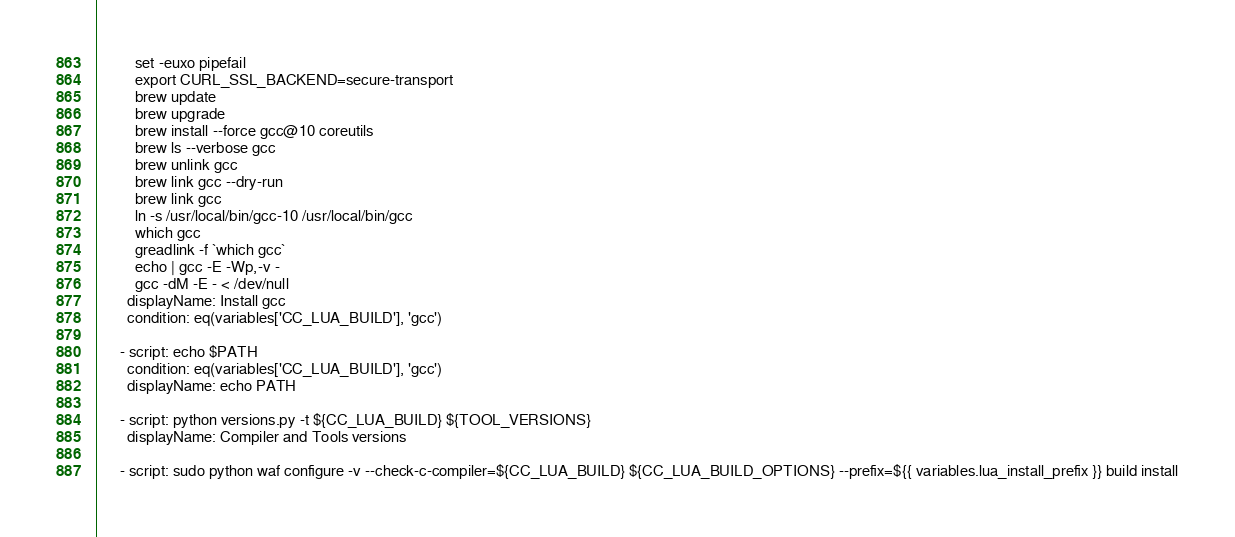<code> <loc_0><loc_0><loc_500><loc_500><_YAML_>          set -euxo pipefail
          export CURL_SSL_BACKEND=secure-transport
          brew update
          brew upgrade
          brew install --force gcc@10 coreutils
          brew ls --verbose gcc
          brew unlink gcc
          brew link gcc --dry-run
          brew link gcc
          ln -s /usr/local/bin/gcc-10 /usr/local/bin/gcc
          which gcc
          greadlink -f `which gcc`
          echo | gcc -E -Wp,-v -
          gcc -dM -E - < /dev/null
        displayName: Install gcc
        condition: eq(variables['CC_LUA_BUILD'], 'gcc')

      - script: echo $PATH
        condition: eq(variables['CC_LUA_BUILD'], 'gcc')
        displayName: echo PATH

      - script: python versions.py -t ${CC_LUA_BUILD} ${TOOL_VERSIONS}
        displayName: Compiler and Tools versions

      - script: sudo python waf configure -v --check-c-compiler=${CC_LUA_BUILD} ${CC_LUA_BUILD_OPTIONS} --prefix=${{ variables.lua_install_prefix }} build install</code> 